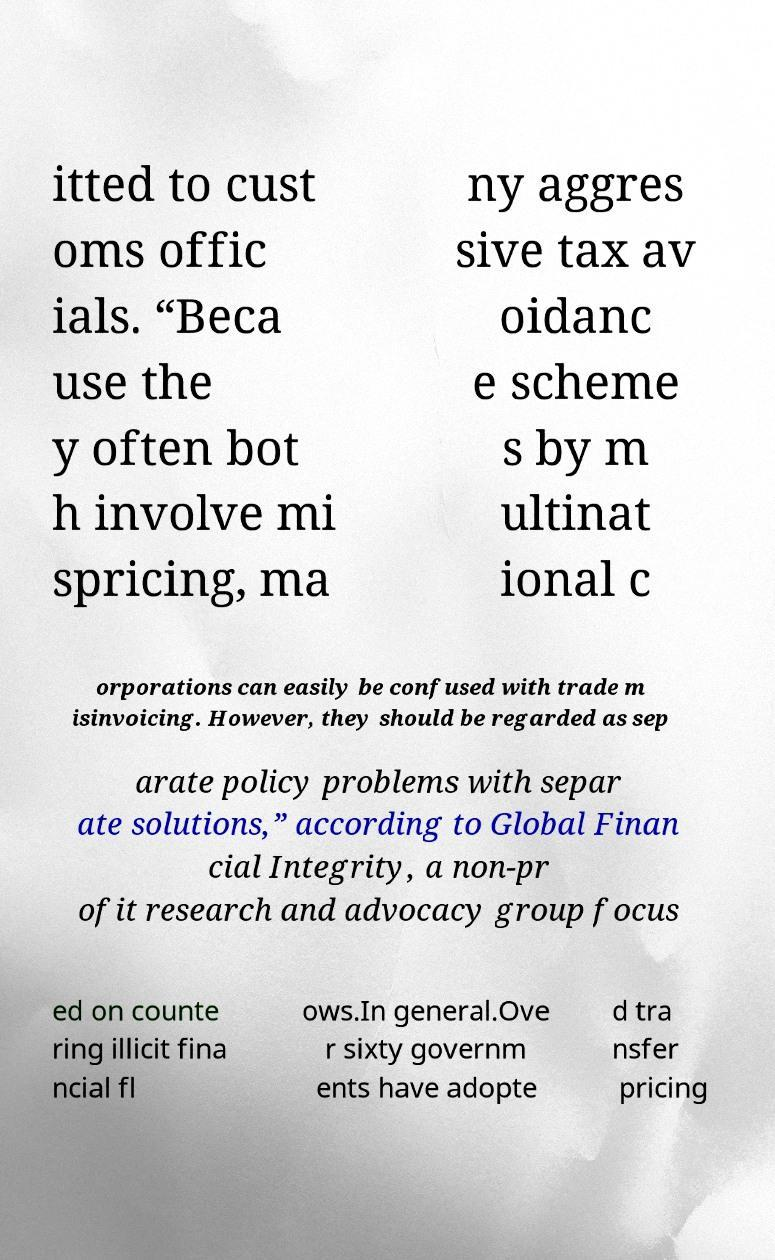For documentation purposes, I need the text within this image transcribed. Could you provide that? itted to cust oms offic ials. “Beca use the y often bot h involve mi spricing, ma ny aggres sive tax av oidanc e scheme s by m ultinat ional c orporations can easily be confused with trade m isinvoicing. However, they should be regarded as sep arate policy problems with separ ate solutions,” according to Global Finan cial Integrity, a non-pr ofit research and advocacy group focus ed on counte ring illicit fina ncial fl ows.In general.Ove r sixty governm ents have adopte d tra nsfer pricing 